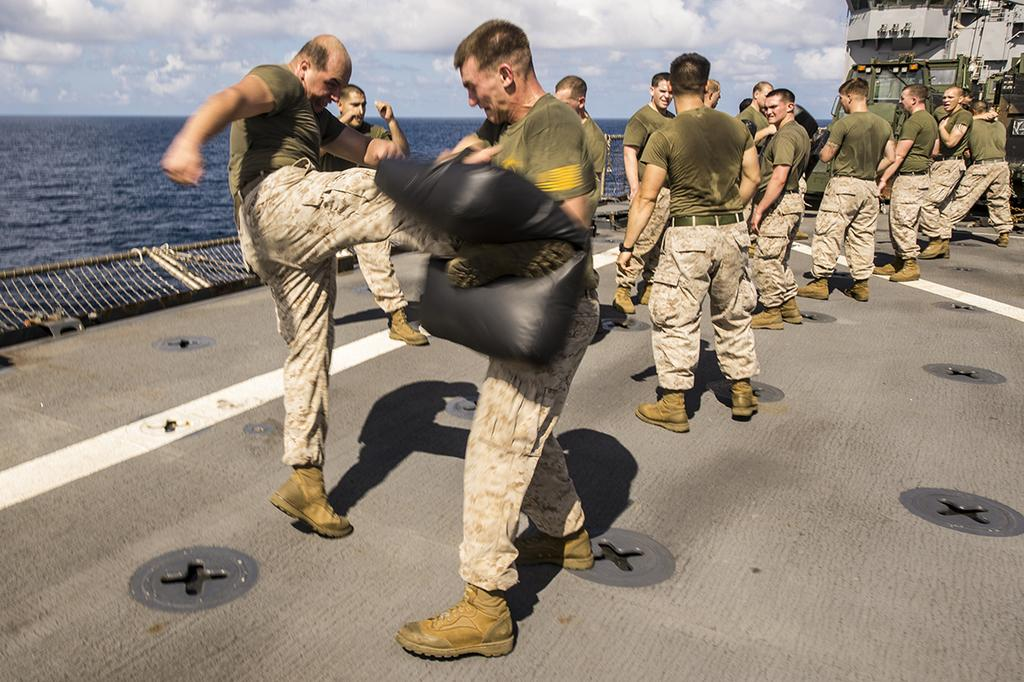What are the people in the image doing? There are soldiers standing in the image. What can be seen in the background of the image? There is water visible in the image. How would you describe the weather in the image? The sky is cloudy in the image. What type of crime is being committed in the image? There is no crime being committed in the image; it features soldiers standing. How does the park contribute to the atmosphere of the image? There is no park present in the image; it only shows soldiers standing and a cloudy sky. 